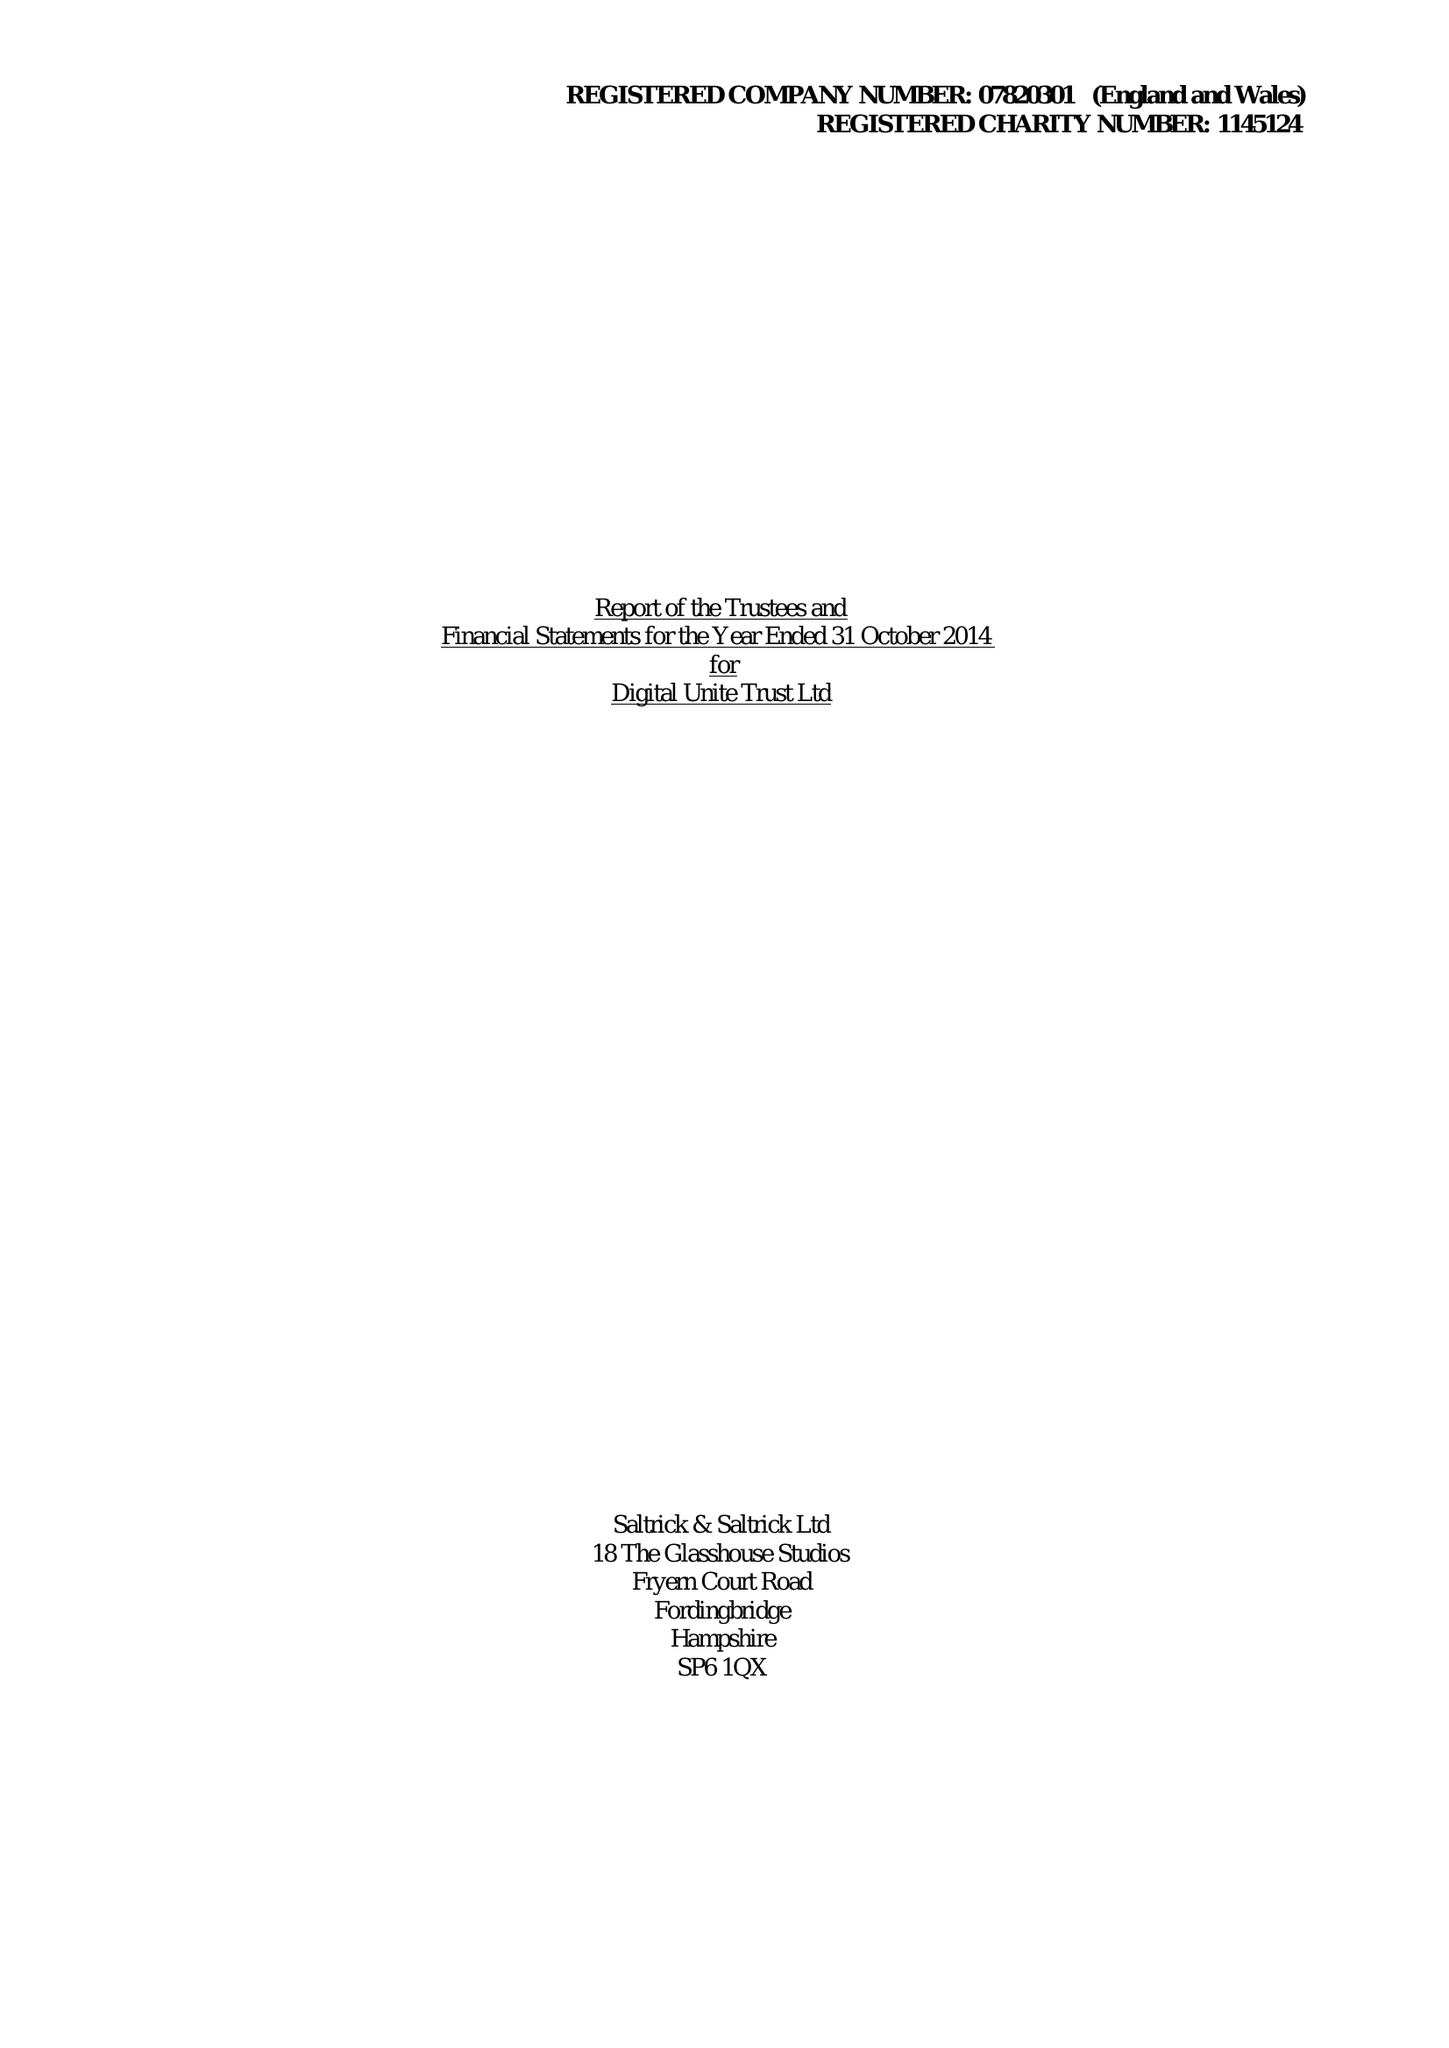What is the value for the address__street_line?
Answer the question using a single word or phrase. None 